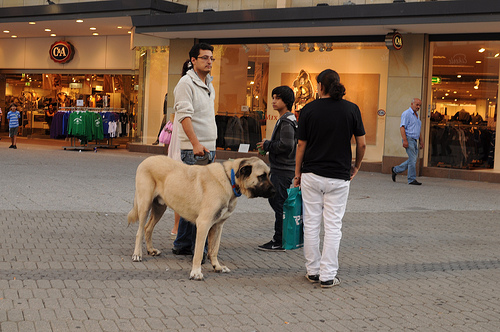Are there chairs to the left of the woman that is wearing a shirt? No, there are no chairs to the left of the woman in the shirt; the area is clear of any seating furniture. 